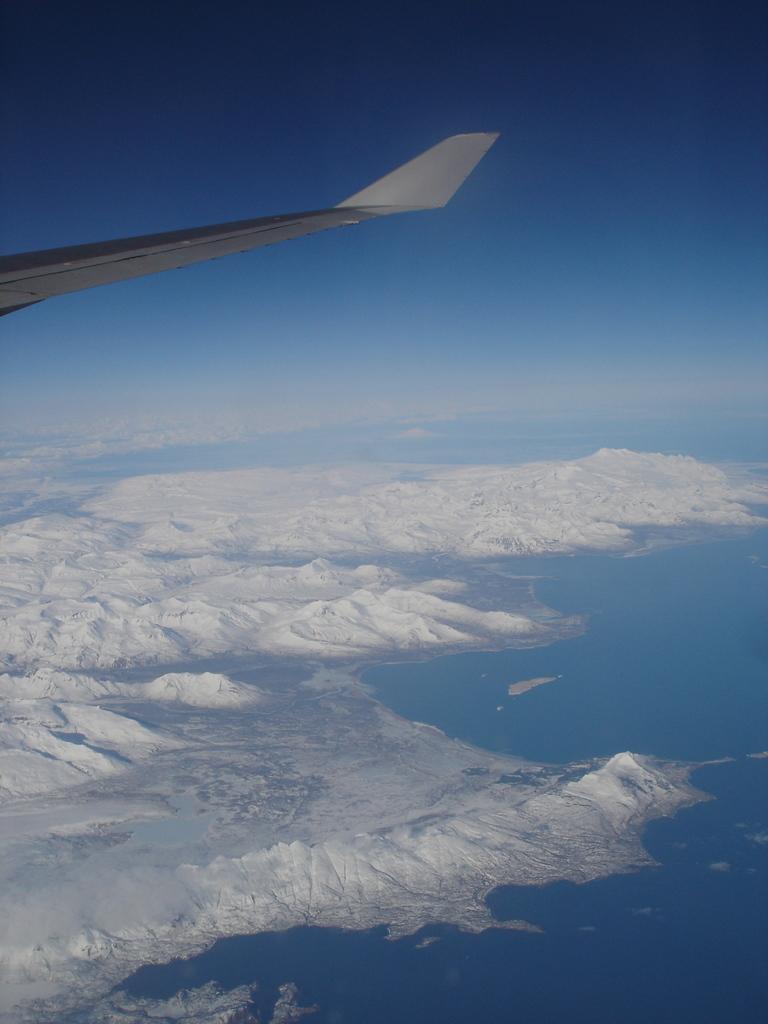Could you give a brief overview of what you see in this image? In the image we can see the wing of the flying jet. Here we can see snow, water and the sky. 